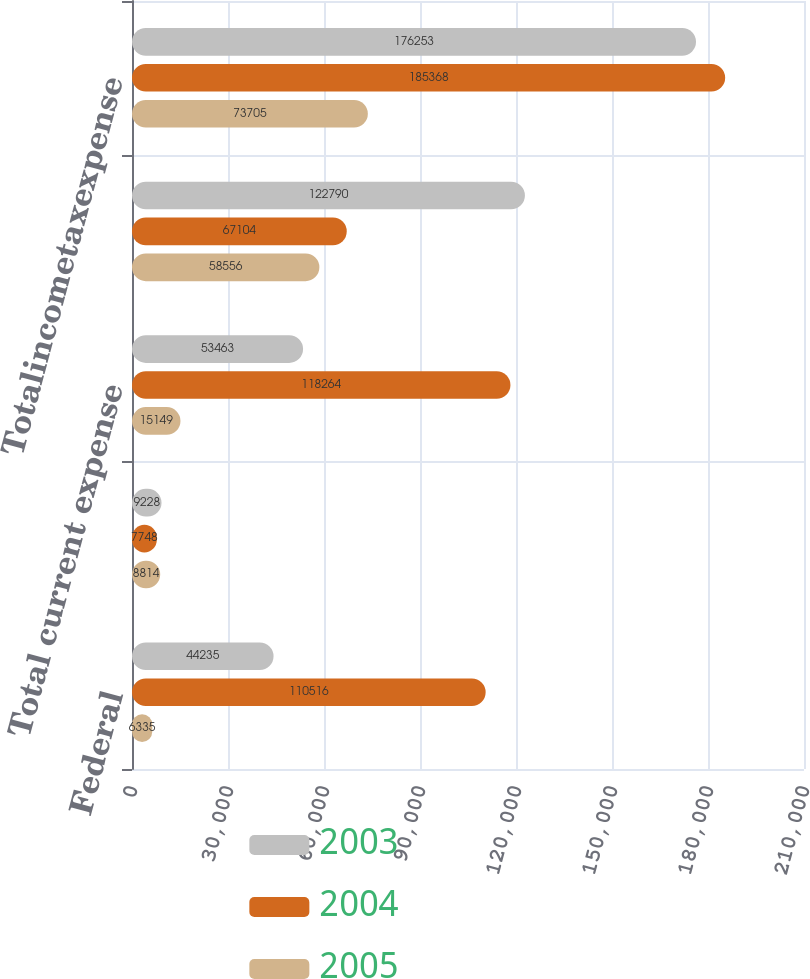Convert chart to OTSL. <chart><loc_0><loc_0><loc_500><loc_500><stacked_bar_chart><ecel><fcel>Federal<fcel>Foreign<fcel>Total current expense<fcel>Total deferred expense<fcel>Totalincometaxexpense<nl><fcel>2003<fcel>44235<fcel>9228<fcel>53463<fcel>122790<fcel>176253<nl><fcel>2004<fcel>110516<fcel>7748<fcel>118264<fcel>67104<fcel>185368<nl><fcel>2005<fcel>6335<fcel>8814<fcel>15149<fcel>58556<fcel>73705<nl></chart> 